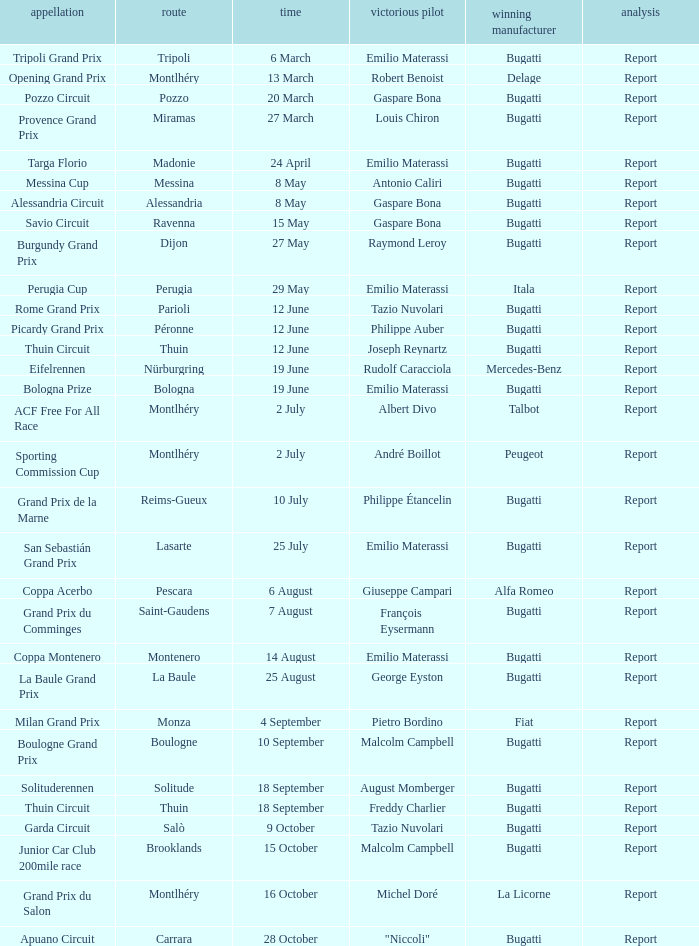Which circuit did françois eysermann win ? Saint-Gaudens. 